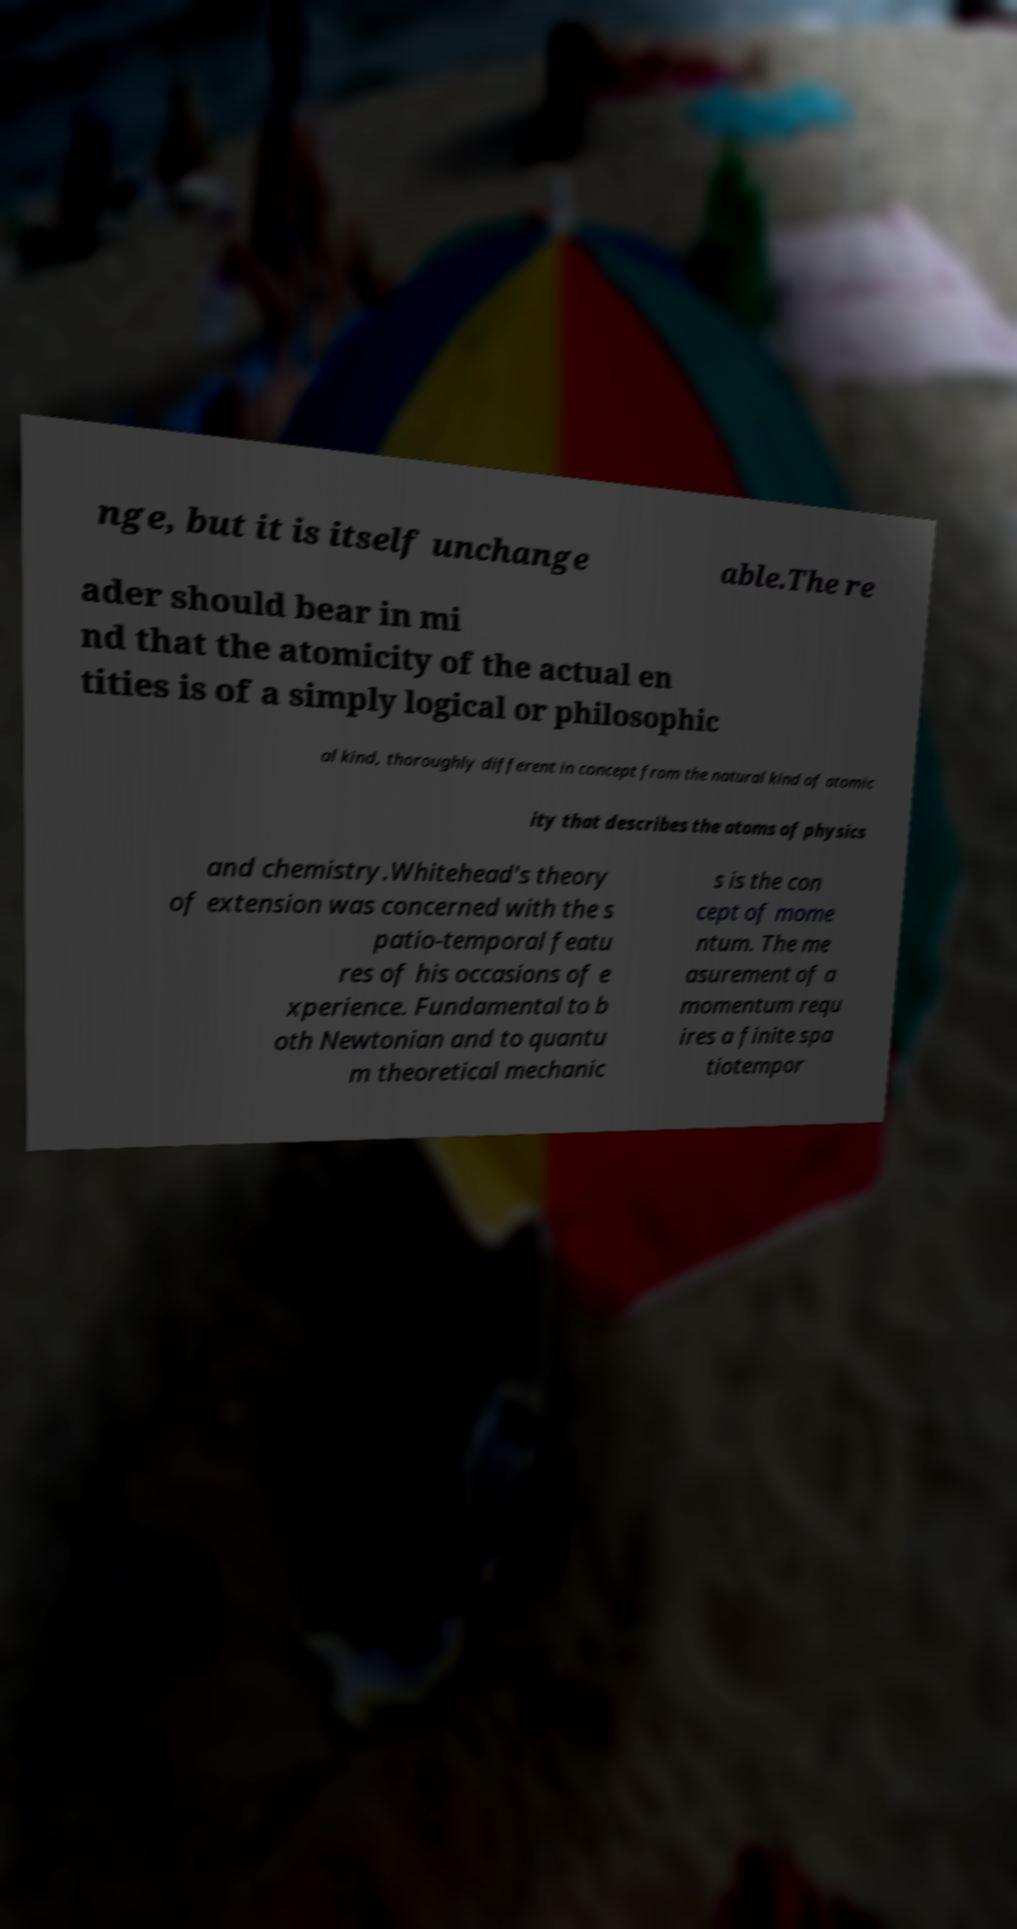Please identify and transcribe the text found in this image. nge, but it is itself unchange able.The re ader should bear in mi nd that the atomicity of the actual en tities is of a simply logical or philosophic al kind, thoroughly different in concept from the natural kind of atomic ity that describes the atoms of physics and chemistry.Whitehead's theory of extension was concerned with the s patio-temporal featu res of his occasions of e xperience. Fundamental to b oth Newtonian and to quantu m theoretical mechanic s is the con cept of mome ntum. The me asurement of a momentum requ ires a finite spa tiotempor 